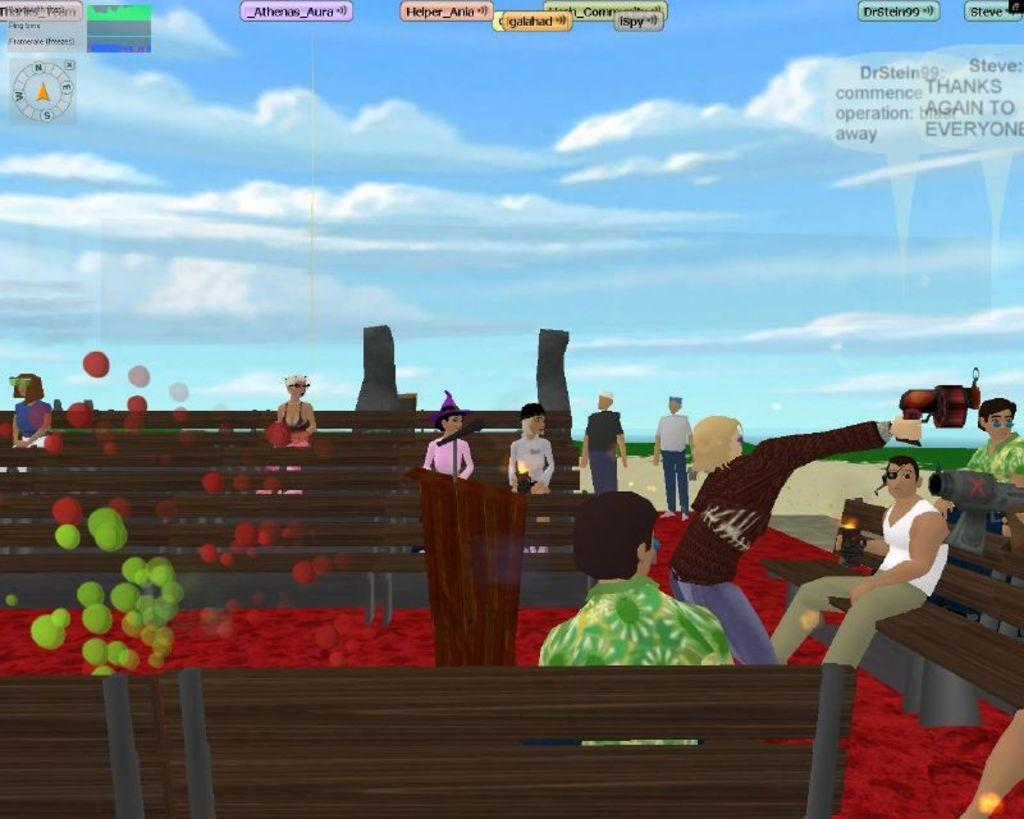What type of image is in the picture? There is a cartoon image in the picture. What are the people in the image doing? People are sitting on benches in the image. What is the man in the image holding? A man is standing and holding a gun in the image. What can be seen in the background of the image? The sky is visible in the background of the image. What is the condition of the sky in the image? Clouds are present in the sky. What is the price of the spot on the bench in the image? There is no price mentioned or implied in the image, as it is a cartoon scene and not a real-life situation. 